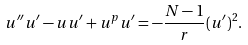Convert formula to latex. <formula><loc_0><loc_0><loc_500><loc_500>u ^ { \prime \prime } u ^ { \prime } - u u ^ { \prime } + u ^ { p } u ^ { \prime } = - \frac { N - 1 } { r } ( u ^ { \prime } ) ^ { 2 } .</formula> 